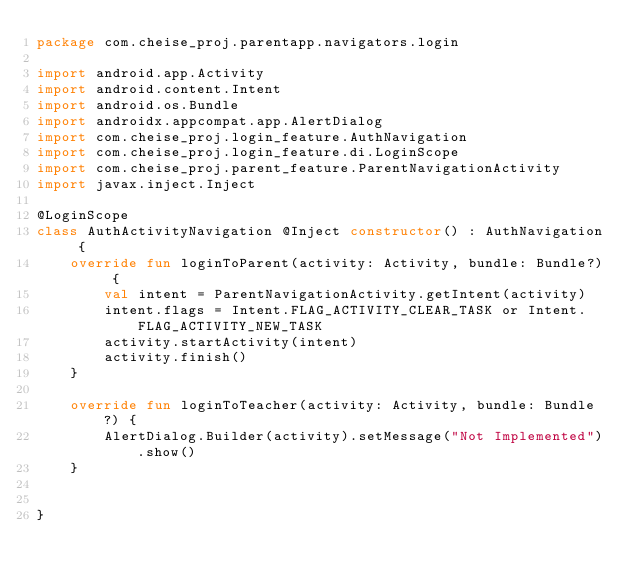<code> <loc_0><loc_0><loc_500><loc_500><_Kotlin_>package com.cheise_proj.parentapp.navigators.login

import android.app.Activity
import android.content.Intent
import android.os.Bundle
import androidx.appcompat.app.AlertDialog
import com.cheise_proj.login_feature.AuthNavigation
import com.cheise_proj.login_feature.di.LoginScope
import com.cheise_proj.parent_feature.ParentNavigationActivity
import javax.inject.Inject

@LoginScope
class AuthActivityNavigation @Inject constructor() : AuthNavigation {
    override fun loginToParent(activity: Activity, bundle: Bundle?) {
        val intent = ParentNavigationActivity.getIntent(activity)
        intent.flags = Intent.FLAG_ACTIVITY_CLEAR_TASK or Intent.FLAG_ACTIVITY_NEW_TASK
        activity.startActivity(intent)
        activity.finish()
    }

    override fun loginToTeacher(activity: Activity, bundle: Bundle?) {
        AlertDialog.Builder(activity).setMessage("Not Implemented").show()
    }


}</code> 